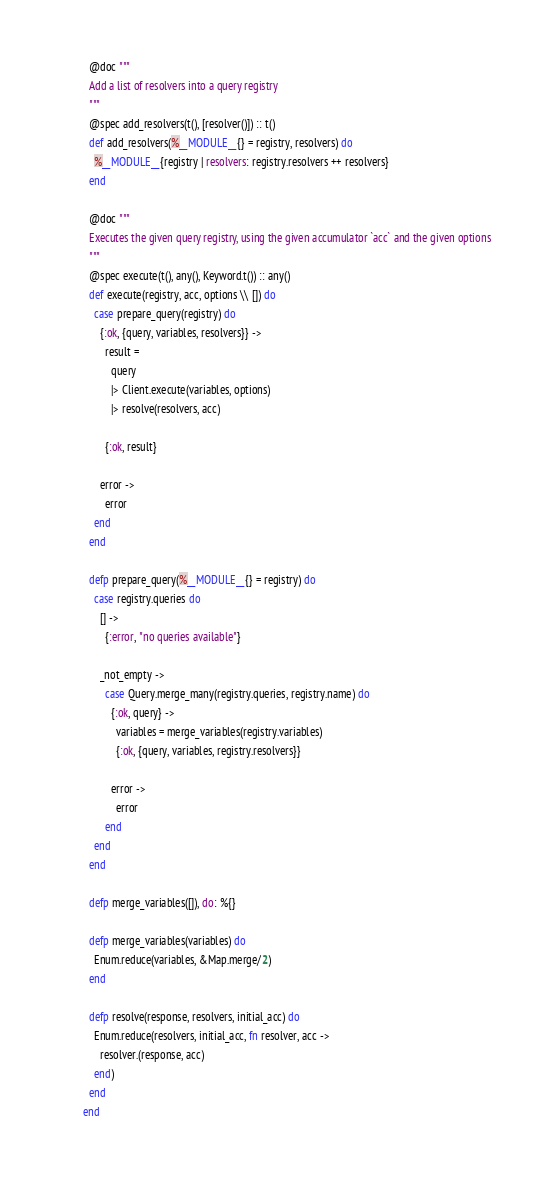Convert code to text. <code><loc_0><loc_0><loc_500><loc_500><_Elixir_>
  @doc """
  Add a list of resolvers into a query registry
  """
  @spec add_resolvers(t(), [resolver()]) :: t()
  def add_resolvers(%__MODULE__{} = registry, resolvers) do
    %__MODULE__{registry | resolvers: registry.resolvers ++ resolvers}
  end

  @doc """
  Executes the given query registry, using the given accumulator `acc` and the given options
  """
  @spec execute(t(), any(), Keyword.t()) :: any()
  def execute(registry, acc, options \\ []) do
    case prepare_query(registry) do
      {:ok, {query, variables, resolvers}} ->
        result =
          query
          |> Client.execute(variables, options)
          |> resolve(resolvers, acc)

        {:ok, result}

      error ->
        error
    end
  end

  defp prepare_query(%__MODULE__{} = registry) do
    case registry.queries do
      [] ->
        {:error, "no queries available"}

      _not_empty ->
        case Query.merge_many(registry.queries, registry.name) do
          {:ok, query} ->
            variables = merge_variables(registry.variables)
            {:ok, {query, variables, registry.resolvers}}

          error ->
            error
        end
    end
  end

  defp merge_variables([]), do: %{}

  defp merge_variables(variables) do
    Enum.reduce(variables, &Map.merge/2)
  end

  defp resolve(response, resolvers, initial_acc) do
    Enum.reduce(resolvers, initial_acc, fn resolver, acc ->
      resolver.(response, acc)
    end)
  end
end
</code> 